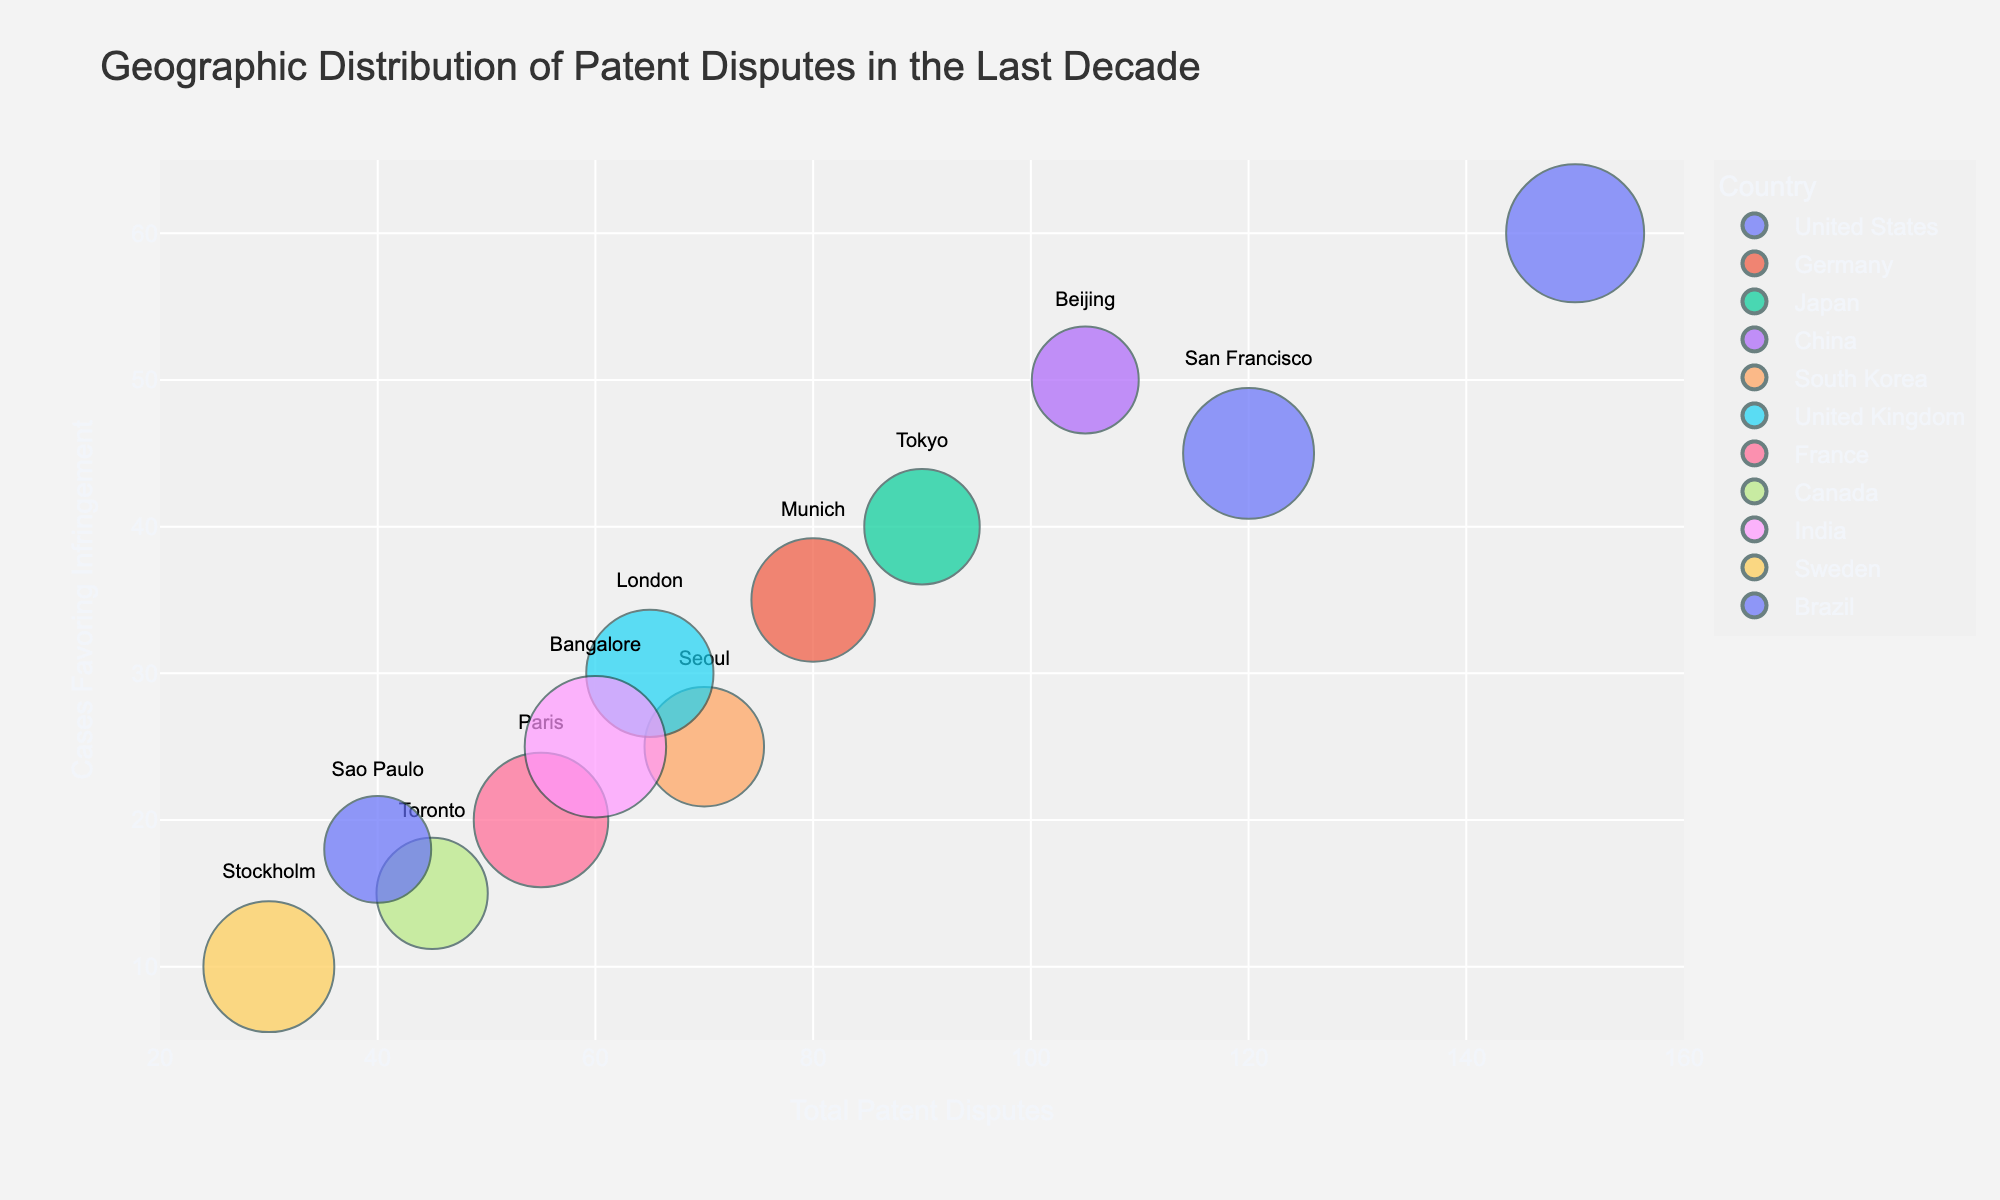What is the title of the figure? The title can be found at the top of the chart and provides a summary of what the figure shows. The title is "Geographic Distribution of Patent Disputes in the Last Decade."
Answer: Geographic Distribution of Patent Disputes in the Last Decade Which city has the largest bubble size in the figure? By examining the size of the bubbles, which represents the Average Case Duration, the city with the largest bubble size is New York.
Answer: New York What is the total number of cities represented in the figure? Each bubble represents a different city. By counting the bubbles, there are 12 cities displayed in the figure.
Answer: 12 Which city has the highest number of patent disputes? Patent disputes are plotted on the x-axis. Identify the bubble that is furthest to the right; this city is New York with 150 patent disputes.
Answer: New York How many cities have an Average Case Duration of over 15 months? By interpreting the bubble size (larger sizes represent longer average case durations), find and count the cities with bubbles larger than those representing a duration of 15 months. The cities are San Francisco, New York, Munich, London, Paris, and Bangalore, making a total of 6 cities.
Answer: 6 Which country has the most cities represented in the figure, and what are those cities? Each country is a unique color in the figure. By counting the number of cities per country, the United States has the most representation with San Francisco and New York.
Answer: United States (San Francisco, New York) Between Tokyo and Beijing, which city has a higher percentage of case outcomes favoring infringement? The y-axis indicates the case outcomes favoring infringement. Compare the two cities' positions on the y-axis. Beijing (50) is higher than Tokyo (40).
Answer: Beijing What is the average Case Outcome Favoring Infringement for all the cities? Sum all the values of ‘Case Outcomes Favoring Infringement’ and divide by the number of cities: (45+60+35+40+50+25+30+20+15+25+10+18)/12. The result is 373/12 = 31.08 (rounded to two decimal places).
Answer: 31.08 Which city has the shortest average case duration and how many months is it? Bubble sizes represent the average case duration, smaller bubbles indicate shorter durations. The smallest bubble corresponds to Sao Paulo with 12 months.
Answer: Sao Paulo (12 months) How many patent disputes are there in cities in Europe indicated in the figure? Sum the patent disputes for the cities located in Europe: Munich (80), London (65), Paris (55), and Stockholm (30). Thus, 80+65+55+30 = 230.
Answer: 230 